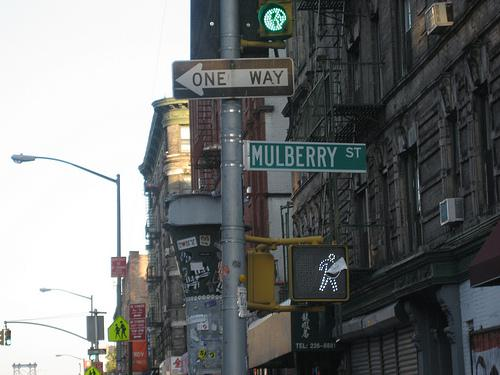Question: why is there a pole?
Choices:
A. To ski around.
B. To hold a sign.
C. Show signs.
D. To hold a light.
Answer with the letter. Answer: C Question: where is the green light?
Choices:
A. On the laser pen.
B. On the stop sign.
C. On the race track.
D. Above the one way sign.
Answer with the letter. Answer: D Question: when is the green light on?
Choices:
A. Now.
B. When it is time to go.
C. When you turn the light on.
D. When the laser pen is being played with.
Answer with the letter. Answer: A Question: what street is on a sign?
Choices:
A. Mulberry.
B. Williams.
C. Garfield.
D. Wint.
Answer with the letter. Answer: A 